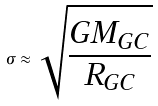Convert formula to latex. <formula><loc_0><loc_0><loc_500><loc_500>\sigma \approx \sqrt { \frac { G M _ { G C } } { R _ { G C } } }</formula> 